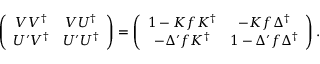<formula> <loc_0><loc_0><loc_500><loc_500>\left ( \begin{array} { c c } { { V V ^ { \dag } } } & { { V U ^ { \dag } } } \\ { { U ^ { \prime } V ^ { \dag } } } & { { U ^ { \prime } U ^ { \dag } } } \end{array} \right ) = \left ( \begin{array} { c c } { { 1 - K f K ^ { \dag } } } & { { - K f \Delta ^ { \dag } } } \\ { { - \Delta ^ { \prime } f K ^ { \dag } } } & { { 1 - \Delta ^ { \prime } f \Delta ^ { \dag } } } \end{array} \right ) .</formula> 